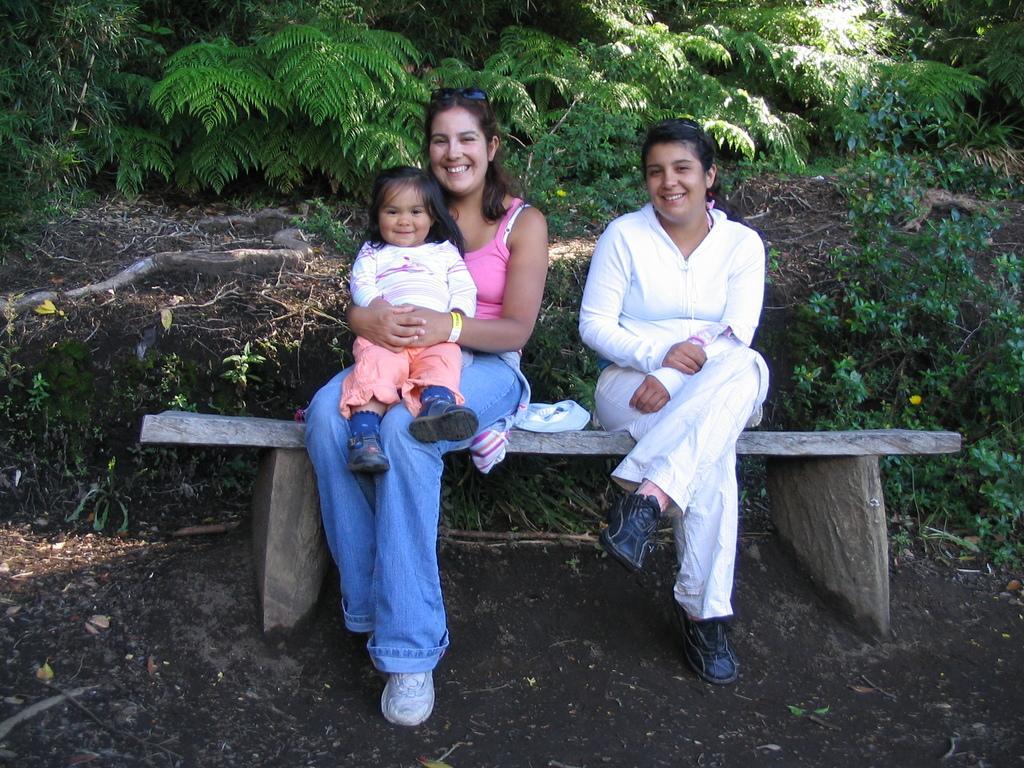Please provide a concise description of this image. In this picture I see 2 women who are sitting on a bench and I see that the woman on the left is holding a baby in her hands. In the background I see the plants. 